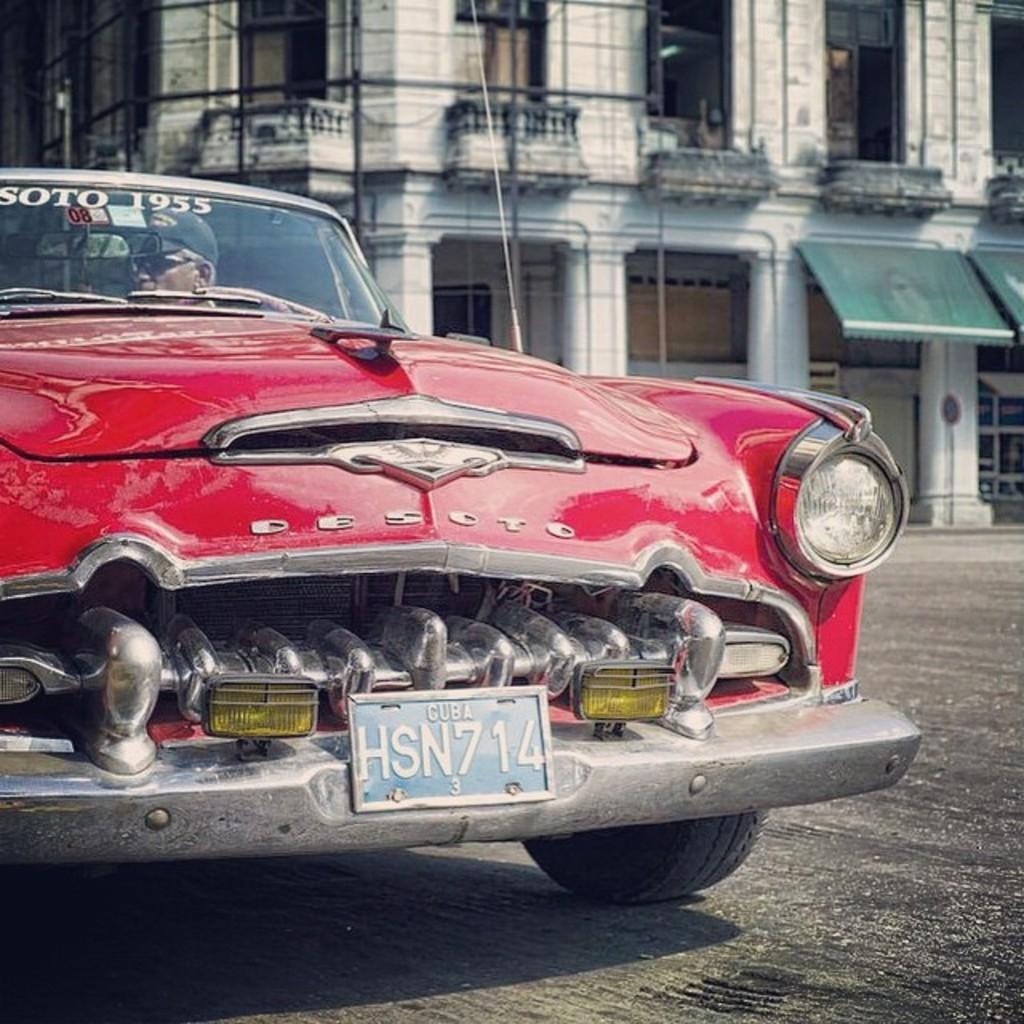Can you describe this image briefly? In this image I see a car which is of red in color and I see the number the number plate on it, on which there are alphabets and numbers written and I see a person sitting in the car and I see the road. In the background I see the building. 